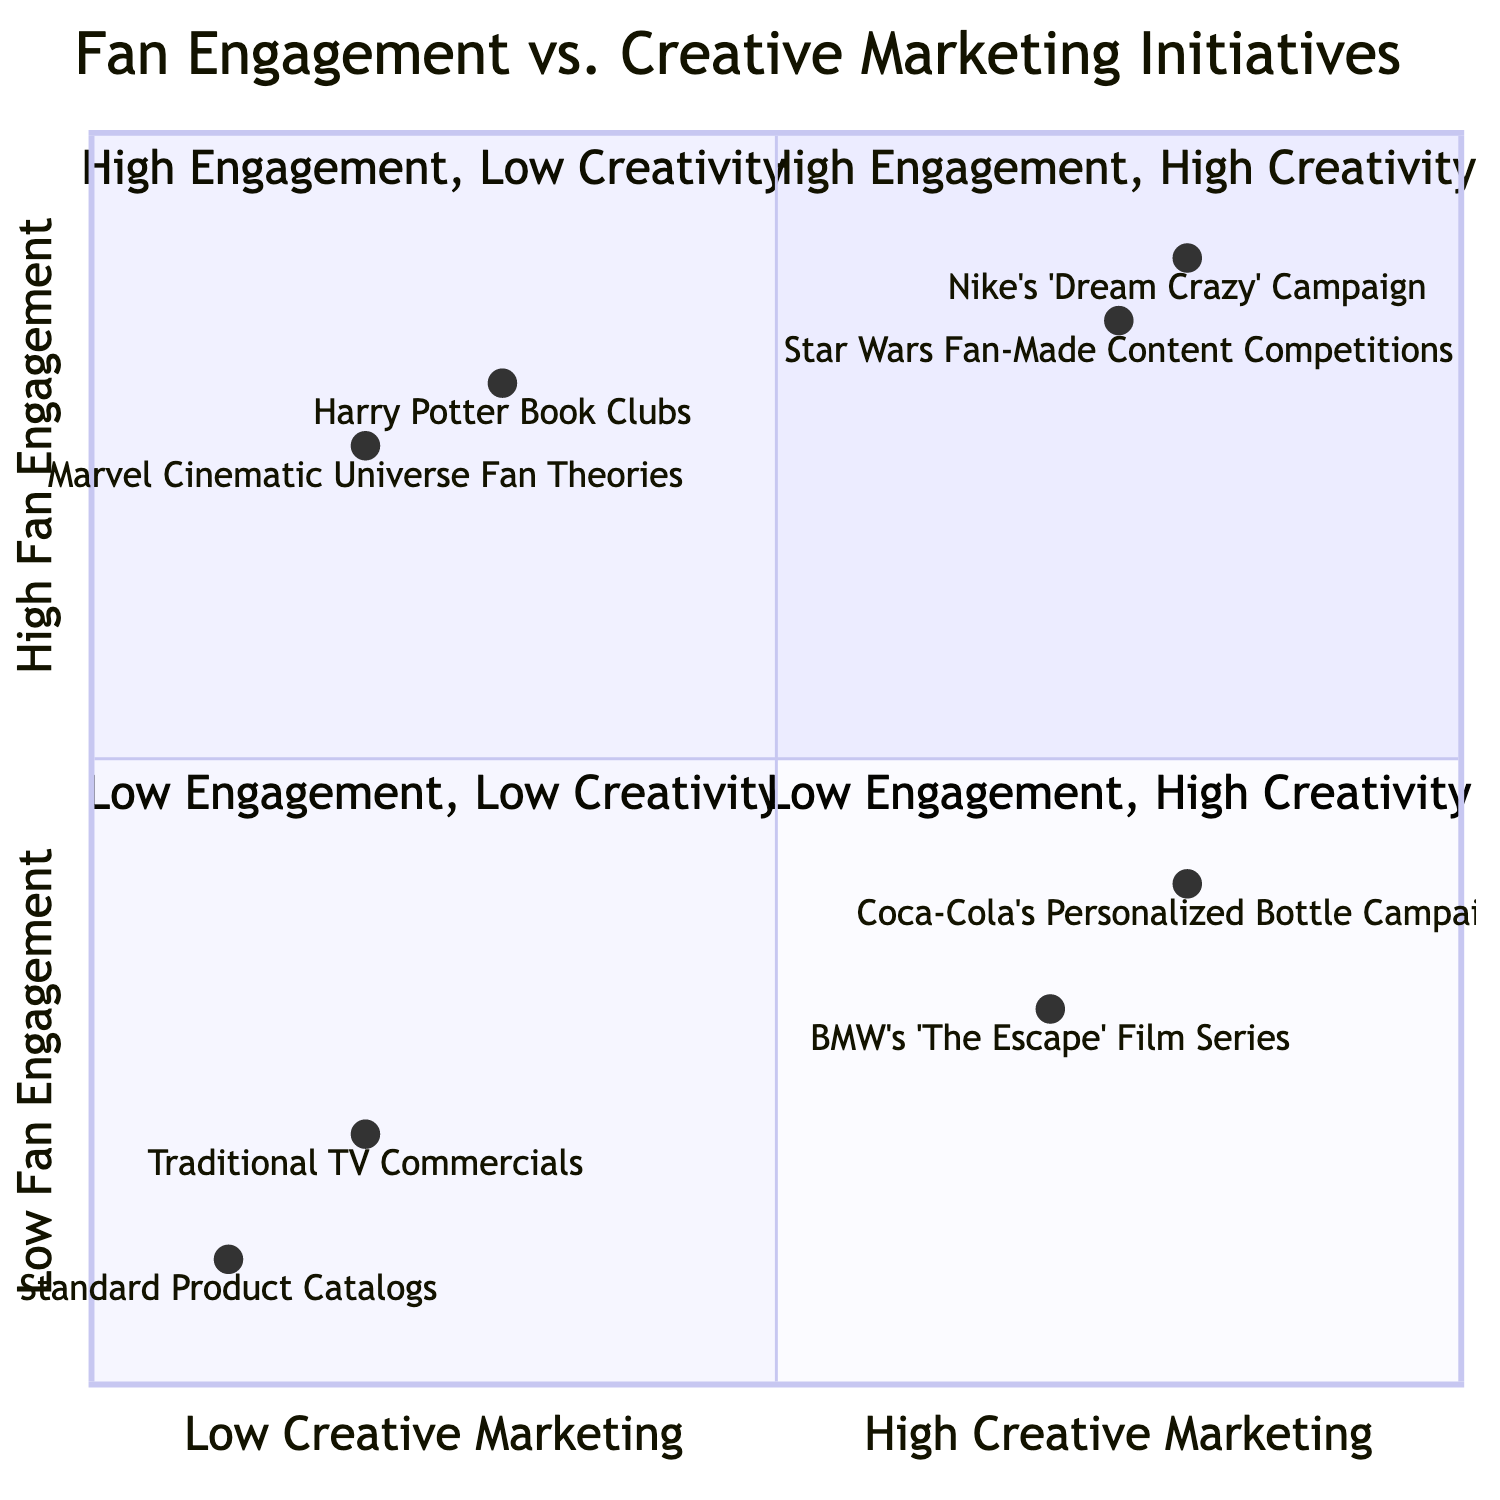What are the examples in the High Fan Engagement and High Creative Marketing quadrant? The first quadrant, representing high fan engagement and high creative marketing, shows "Nike's 'Dream Crazy' Campaign" and "Star Wars Fan-Made Content Competitions."
Answer: Nike's 'Dream Crazy' Campaign, Star Wars Fan-Made Content Competitions Which quadrant contains Harry Potter Book Clubs? "Harry Potter Book Clubs" is located in the second quadrant, which represents high fan engagement but low creative marketing.
Answer: High Engagement, Low Creativity How many initiatives are in the Low Fan Engagement and High Creative Marketing quadrant? The fourth quadrant includes "BMW's 'The Escape' Film Series" and "Coca-Cola's Personalized Bottle Campaign," totaling two initiatives.
Answer: 2 What is the engagement rating for Traditional TV Commercials? "Traditional TV Commercials" is situated in the third quadrant, with a fan engagement rating of 0.2.
Answer: 0.2 Which initiative has the highest creative marketing score? Examining the positions of the initiatives, "Coca-Cola's Personalized Bottle Campaign" has the highest creative marketing score at 0.8.
Answer: Coca-Cola's Personalized Bottle Campaign Which quadrant represents both low fan engagement and low creative marketing? The third quadrant represents both low fan engagement and low creative marketing, including "Traditional TV Commercials" and "Standard Product Catalogs."
Answer: Low Engagement, Low Creativity How many total initiatives are located in the High Creative Marketing area? In the diagram, both Quads 1 and 4 represent high creative marketing, which includes 4 initiatives: "Nike's 'Dream Crazy' Campaign," "Star Wars Fan-Made Content Competitions," "BMW's 'The Escape' Film Series," and "Coca-Cola's Personalized Bottle Campaign."
Answer: 4 What is the creative marketing score for Marvel Cinematic Universe Fan Theories? The creative marketing score for "Marvel Cinematic Universe Fan Theories" is 0.2, as seen in its quadrant position.
Answer: 0.2 